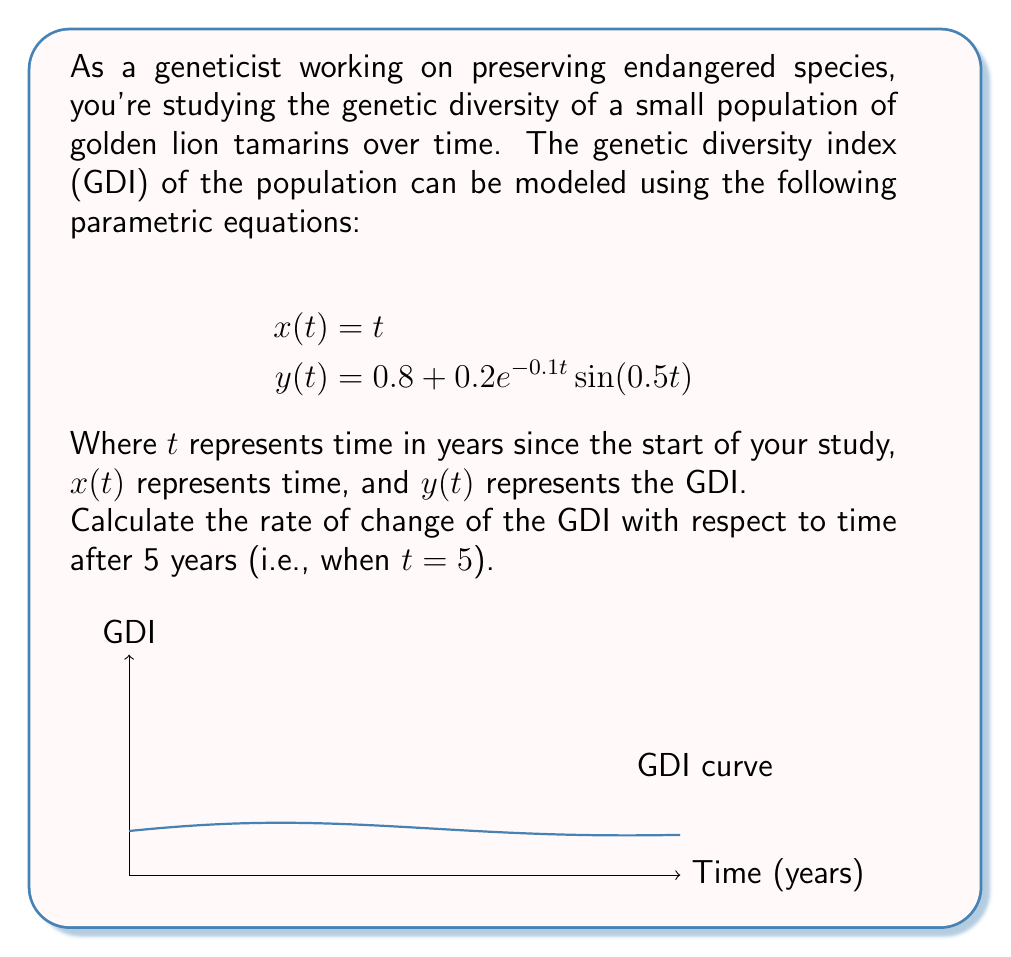Could you help me with this problem? To solve this problem, we need to follow these steps:

1) The rate of change of GDI with respect to time is given by $\frac{dy}{dx}$. In parametric equations, this is calculated as:

   $$\frac{dy}{dx} = \frac{\frac{dy}{dt}}{\frac{dx}{dt}}$$

2) First, let's calculate $\frac{dx}{dt}$:
   $$\frac{dx}{dt} = 1$$ (since $x(t) = t$)

3) Now, let's calculate $\frac{dy}{dt}$:
   $$\begin{align}
   \frac{dy}{dt} &= \frac{d}{dt}[0.8 + 0.2e^{-0.1t}\sin(0.5t)] \\
   &= 0.2\frac{d}{dt}[e^{-0.1t}\sin(0.5t)] \\
   &= 0.2[(-0.1e^{-0.1t}\sin(0.5t)) + (e^{-0.1t}\cos(0.5t)0.5)] \\
   &= 0.2e^{-0.1t}[-0.1\sin(0.5t) + 0.5\cos(0.5t)]
   \end{align}$$

4) Therefore, $\frac{dy}{dx} = \frac{dy}{dt} \div \frac{dx}{dt}$ is:
   $$\frac{dy}{dx} = 0.2e^{-0.1t}[-0.1\sin(0.5t) + 0.5\cos(0.5t)]$$

5) Now, we need to evaluate this at $t = 5$:
   $$\begin{align}
   \left.\frac{dy}{dx}\right|_{t=5} &= 0.2e^{-0.1(5)}[-0.1\sin(0.5(5)) + 0.5\cos(0.5(5))] \\
   &= 0.2e^{-0.5}[-0.1\sin(2.5) + 0.5\cos(2.5)] \\
   &\approx 0.0494
   \end{align}$$
Answer: $0.0494$ 